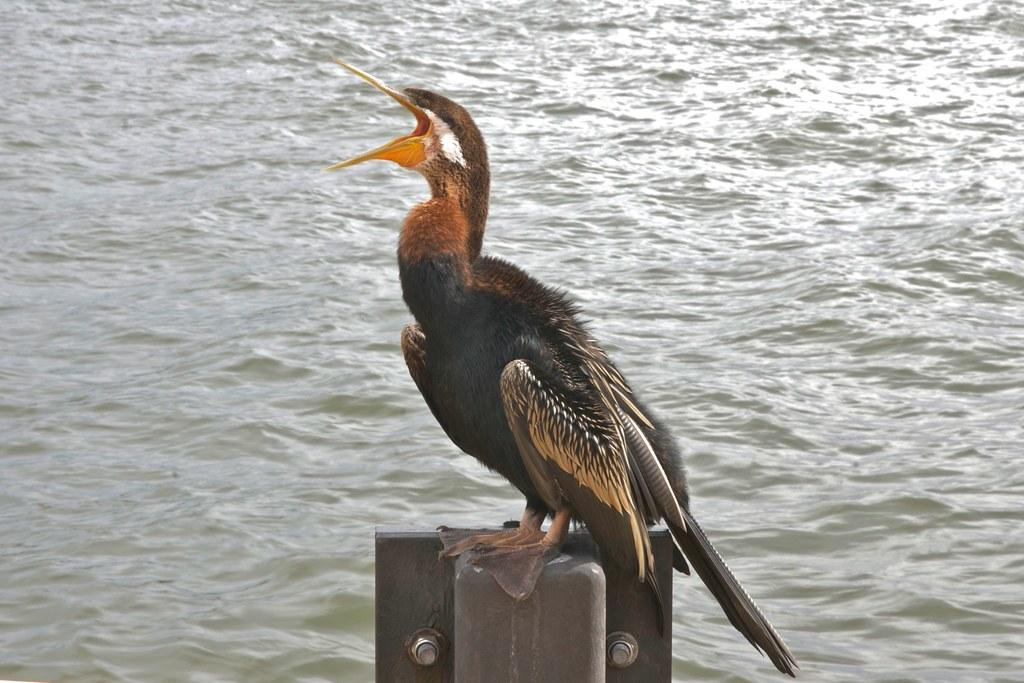What type of animal can be seen in the image? There is a bird in the image. Where is the bird located? The bird is on a metal pole. What else can be seen in the image besides the bird? There is water visible in the image. What colors can be observed on the bird? The bird has black, orange, and cream colors. Who is the creator of the bird in the image? The image does not provide information about the bird's creator, as it is a photograph of a real bird. Can you see any lips on the bird in the image? There are no lips visible on the bird in the image, as birds do not have lips. 